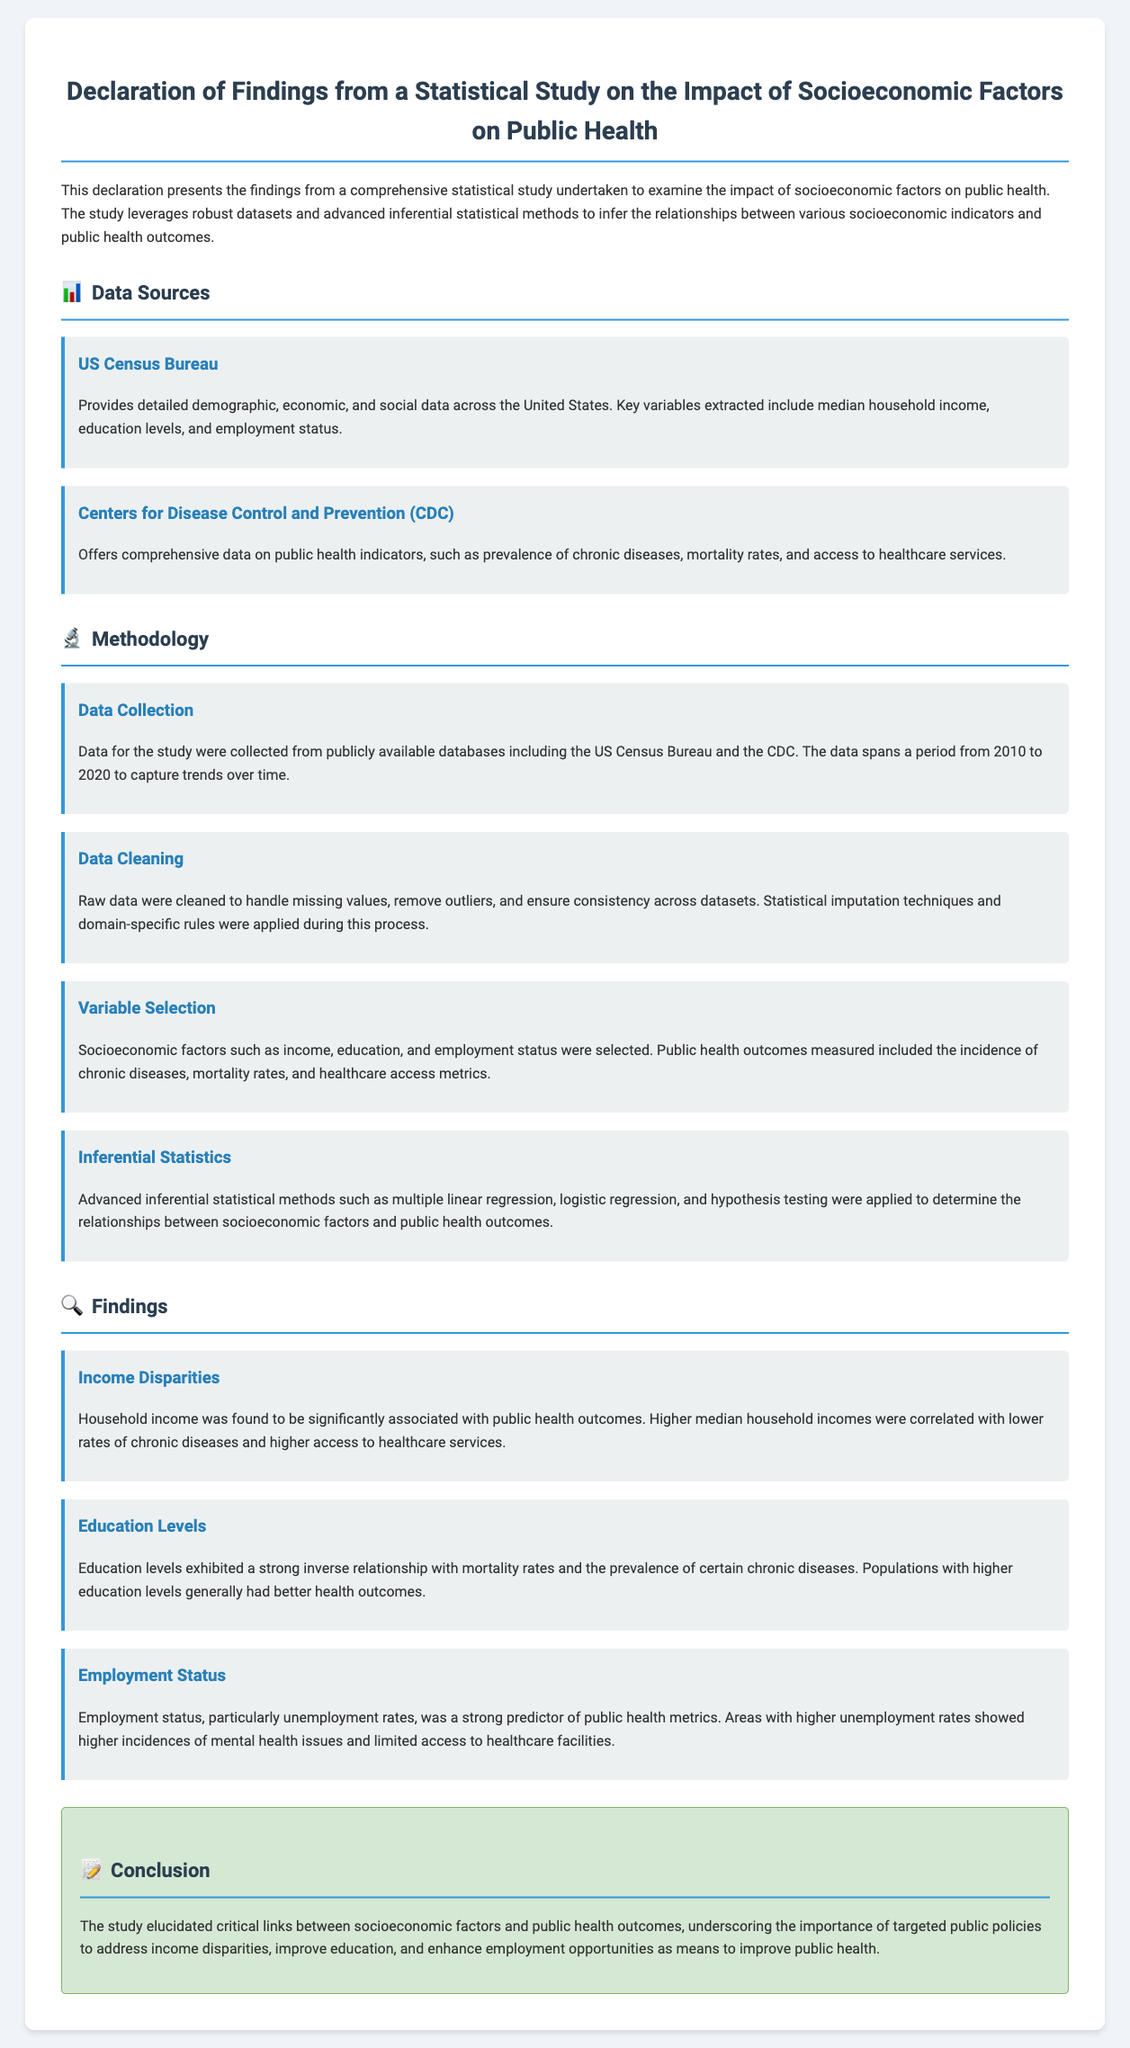What are the data sources used in the study? The study utilizes data from the US Census Bureau and the Centers for Disease Control and Prevention (CDC).
Answer: US Census Bureau and CDC What time period does the data cover? The data spans a period from 2010 to 2020 to capture trends over time.
Answer: 2010 to 2020 Which socioeconomic factor was found to be significantly associated with public health outcomes? Household income was found to have a significant association with public health outcomes, particularly in correlation with chronic disease rates.
Answer: Household income What statistical methods were applied in the study? The study applied multiple linear regression, logistic regression, and hypothesis testing as inferential statistical methods.
Answer: Multiple linear regression, logistic regression, and hypothesis testing What is a key finding related to education levels? Higher education levels exhibited a strong inverse relationship with mortality rates and prevalence of chronic diseases.
Answer: Strong inverse relationship with mortality rates What public health issue is indicated by higher unemployment rates? Higher unemployment rates showed higher incidences of mental health issues and limited access to healthcare facilities.
Answer: Mental health issues What is the conclusion drawn from the findings? The study emphasized the importance of targeted public policies to address income disparities, improve education, and enhance employment opportunities as means to improve public health.
Answer: Targeted public policies How many methodology steps are outlined in the document? There are four distinct methodology steps outlined in the methodology section.
Answer: Four 